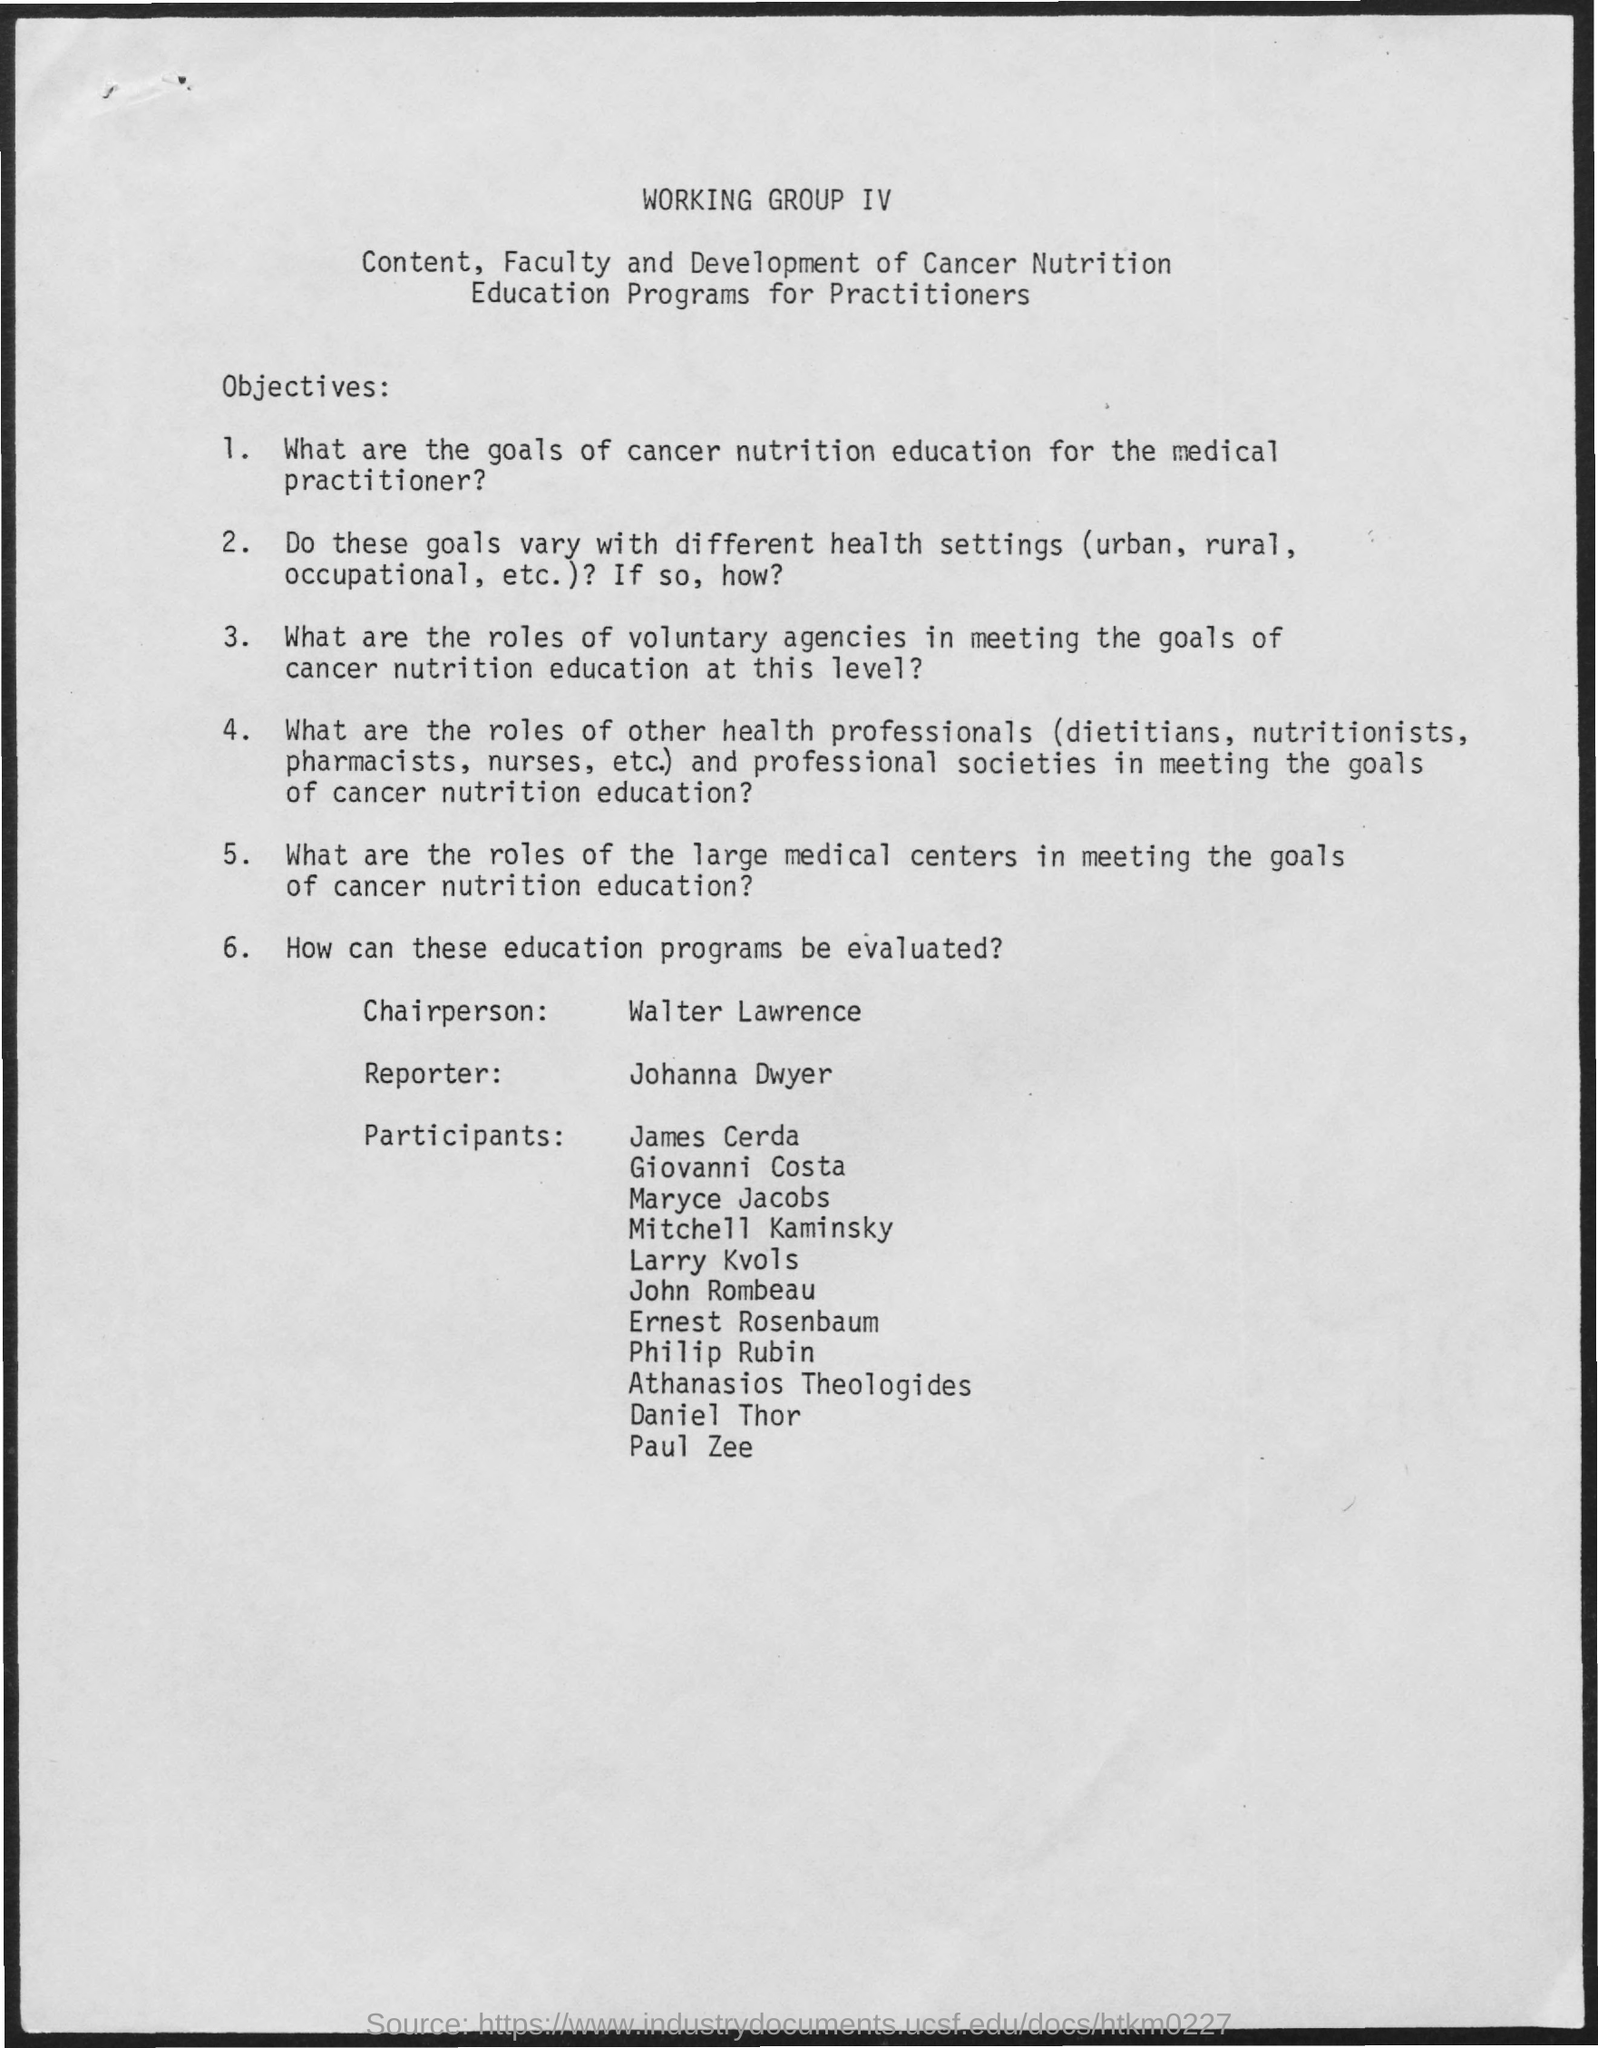Who is listed as the reporter for the working group detailed in this document? Johanna Dwyer is listed as the reporter for the working group presented in the document. 